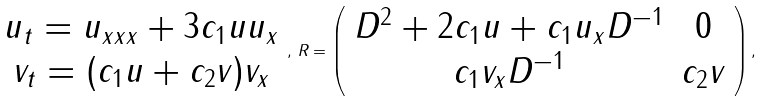Convert formula to latex. <formula><loc_0><loc_0><loc_500><loc_500>\begin{array} { c } u _ { t } = u _ { x x x } + 3 c _ { 1 } u u _ { x } \\ v _ { t } = ( c _ { 1 } u + c _ { 2 } v ) v _ { x } \end{array} , \, R = \left ( \begin{array} { c c } D ^ { 2 } + 2 c _ { 1 } u + c _ { 1 } u _ { x } D ^ { - 1 } & 0 \\ c _ { 1 } v _ { x } D ^ { - 1 } & c _ { 2 } v \end{array} \right ) ,</formula> 